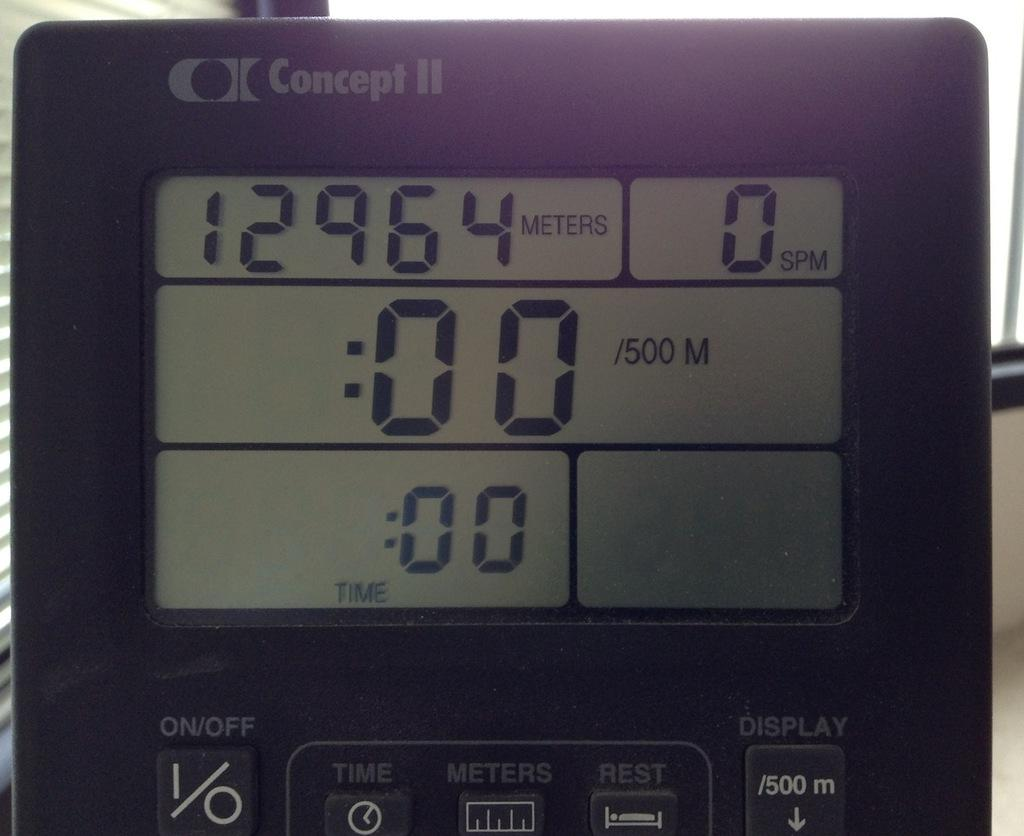<image>
Offer a succinct explanation of the picture presented. Digital meters tracker display brand Concept II and numbers 12964 meters 